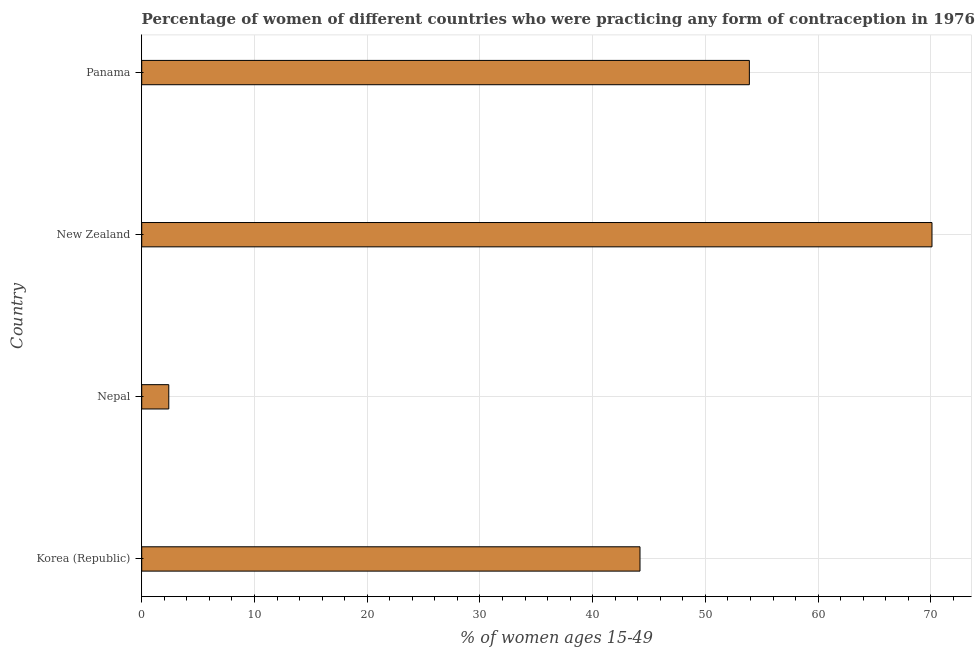Does the graph contain any zero values?
Keep it short and to the point. No. Does the graph contain grids?
Offer a terse response. Yes. What is the title of the graph?
Your answer should be compact. Percentage of women of different countries who were practicing any form of contraception in 1976. What is the label or title of the X-axis?
Provide a short and direct response. % of women ages 15-49. What is the contraceptive prevalence in Korea (Republic)?
Your answer should be very brief. 44.2. Across all countries, what is the maximum contraceptive prevalence?
Your answer should be compact. 70.1. In which country was the contraceptive prevalence maximum?
Keep it short and to the point. New Zealand. In which country was the contraceptive prevalence minimum?
Ensure brevity in your answer.  Nepal. What is the sum of the contraceptive prevalence?
Offer a very short reply. 170.6. What is the difference between the contraceptive prevalence in New Zealand and Panama?
Give a very brief answer. 16.2. What is the average contraceptive prevalence per country?
Keep it short and to the point. 42.65. What is the median contraceptive prevalence?
Give a very brief answer. 49.05. What is the ratio of the contraceptive prevalence in Korea (Republic) to that in New Zealand?
Ensure brevity in your answer.  0.63. Is the sum of the contraceptive prevalence in Korea (Republic) and Nepal greater than the maximum contraceptive prevalence across all countries?
Your answer should be very brief. No. What is the difference between the highest and the lowest contraceptive prevalence?
Give a very brief answer. 67.7. In how many countries, is the contraceptive prevalence greater than the average contraceptive prevalence taken over all countries?
Your answer should be compact. 3. How many bars are there?
Keep it short and to the point. 4. How many countries are there in the graph?
Provide a succinct answer. 4. What is the difference between two consecutive major ticks on the X-axis?
Offer a terse response. 10. What is the % of women ages 15-49 of Korea (Republic)?
Your response must be concise. 44.2. What is the % of women ages 15-49 of Nepal?
Offer a terse response. 2.4. What is the % of women ages 15-49 in New Zealand?
Offer a terse response. 70.1. What is the % of women ages 15-49 in Panama?
Your answer should be compact. 53.9. What is the difference between the % of women ages 15-49 in Korea (Republic) and Nepal?
Provide a short and direct response. 41.8. What is the difference between the % of women ages 15-49 in Korea (Republic) and New Zealand?
Provide a short and direct response. -25.9. What is the difference between the % of women ages 15-49 in Korea (Republic) and Panama?
Your answer should be very brief. -9.7. What is the difference between the % of women ages 15-49 in Nepal and New Zealand?
Offer a terse response. -67.7. What is the difference between the % of women ages 15-49 in Nepal and Panama?
Your answer should be compact. -51.5. What is the difference between the % of women ages 15-49 in New Zealand and Panama?
Offer a terse response. 16.2. What is the ratio of the % of women ages 15-49 in Korea (Republic) to that in Nepal?
Make the answer very short. 18.42. What is the ratio of the % of women ages 15-49 in Korea (Republic) to that in New Zealand?
Make the answer very short. 0.63. What is the ratio of the % of women ages 15-49 in Korea (Republic) to that in Panama?
Your response must be concise. 0.82. What is the ratio of the % of women ages 15-49 in Nepal to that in New Zealand?
Provide a short and direct response. 0.03. What is the ratio of the % of women ages 15-49 in Nepal to that in Panama?
Give a very brief answer. 0.04. What is the ratio of the % of women ages 15-49 in New Zealand to that in Panama?
Your response must be concise. 1.3. 